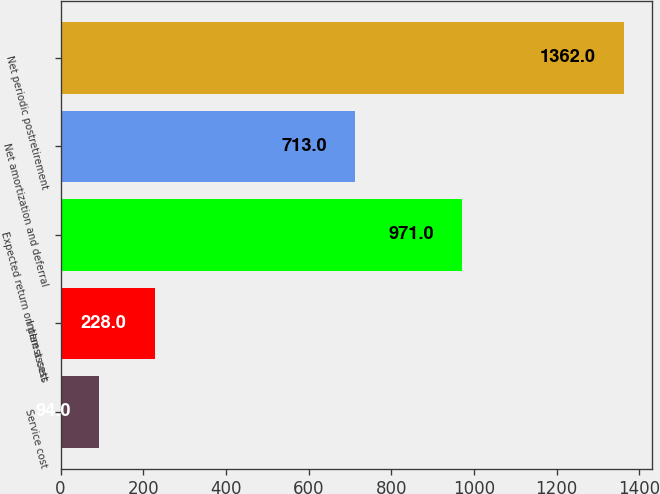Convert chart to OTSL. <chart><loc_0><loc_0><loc_500><loc_500><bar_chart><fcel>Service cost<fcel>Interest cost<fcel>Expected return on plan assets<fcel>Net amortization and deferral<fcel>Net periodic postretirement<nl><fcel>94<fcel>228<fcel>971<fcel>713<fcel>1362<nl></chart> 